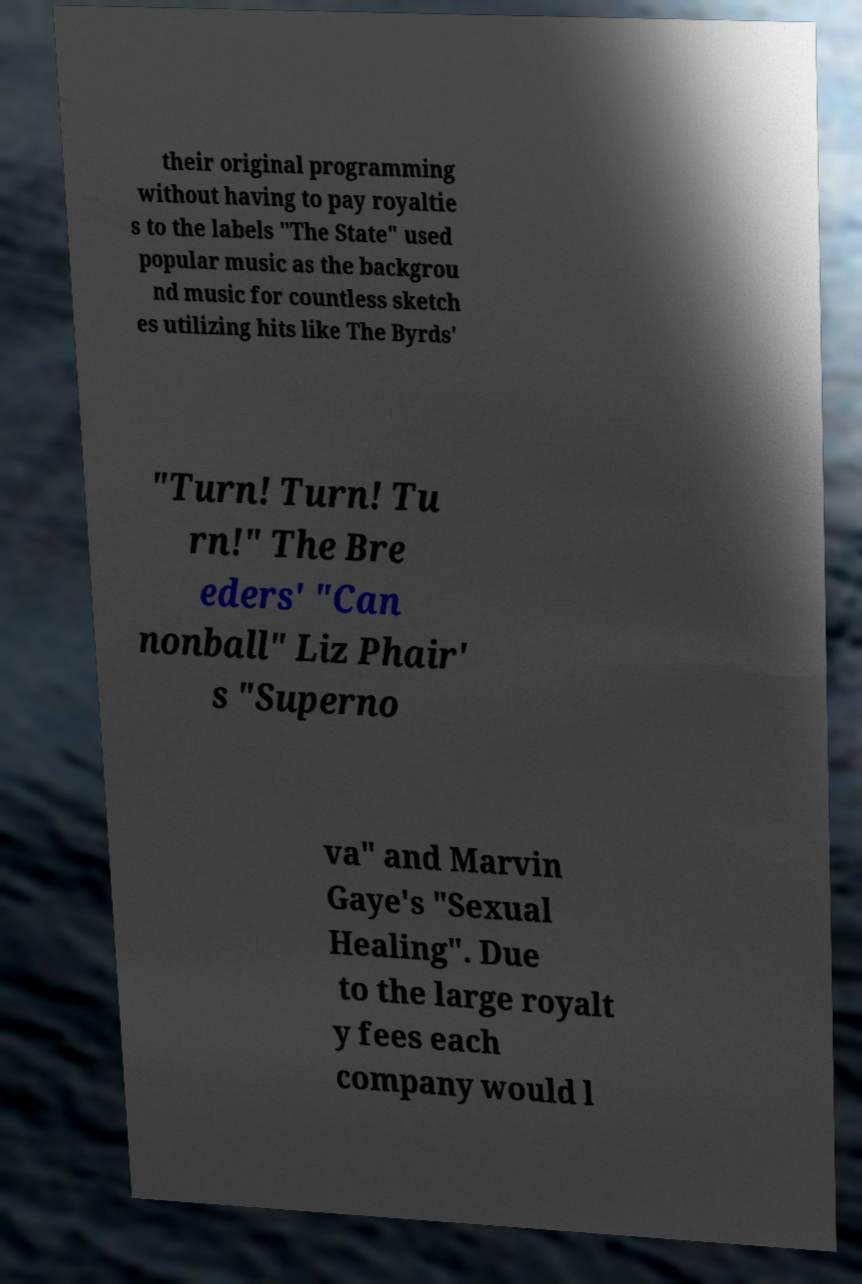Please identify and transcribe the text found in this image. their original programming without having to pay royaltie s to the labels "The State" used popular music as the backgrou nd music for countless sketch es utilizing hits like The Byrds' "Turn! Turn! Tu rn!" The Bre eders' "Can nonball" Liz Phair' s "Superno va" and Marvin Gaye's "Sexual Healing". Due to the large royalt y fees each company would l 